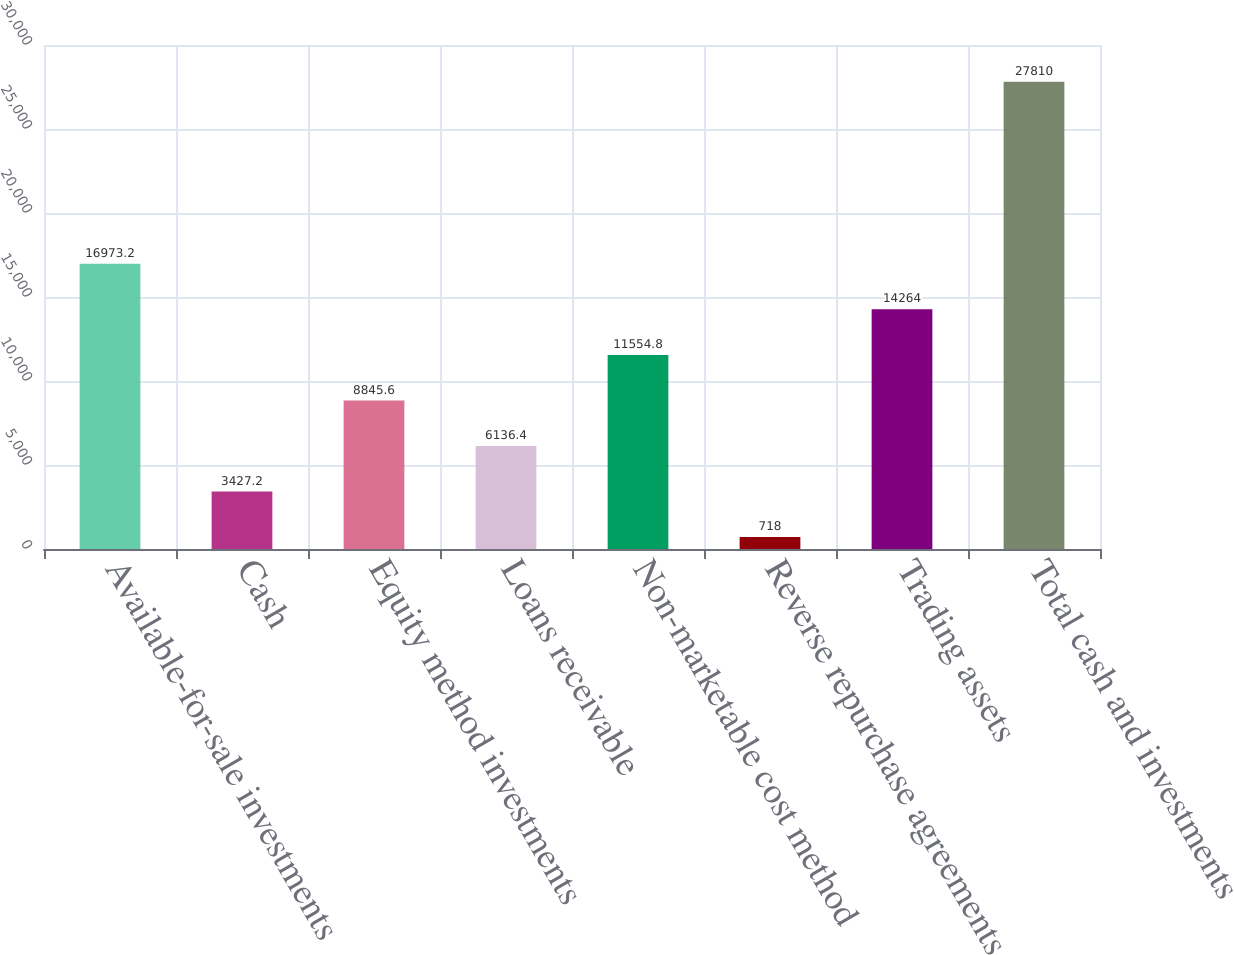<chart> <loc_0><loc_0><loc_500><loc_500><bar_chart><fcel>Available-for-sale investments<fcel>Cash<fcel>Equity method investments<fcel>Loans receivable<fcel>Non-marketable cost method<fcel>Reverse repurchase agreements<fcel>Trading assets<fcel>Total cash and investments<nl><fcel>16973.2<fcel>3427.2<fcel>8845.6<fcel>6136.4<fcel>11554.8<fcel>718<fcel>14264<fcel>27810<nl></chart> 